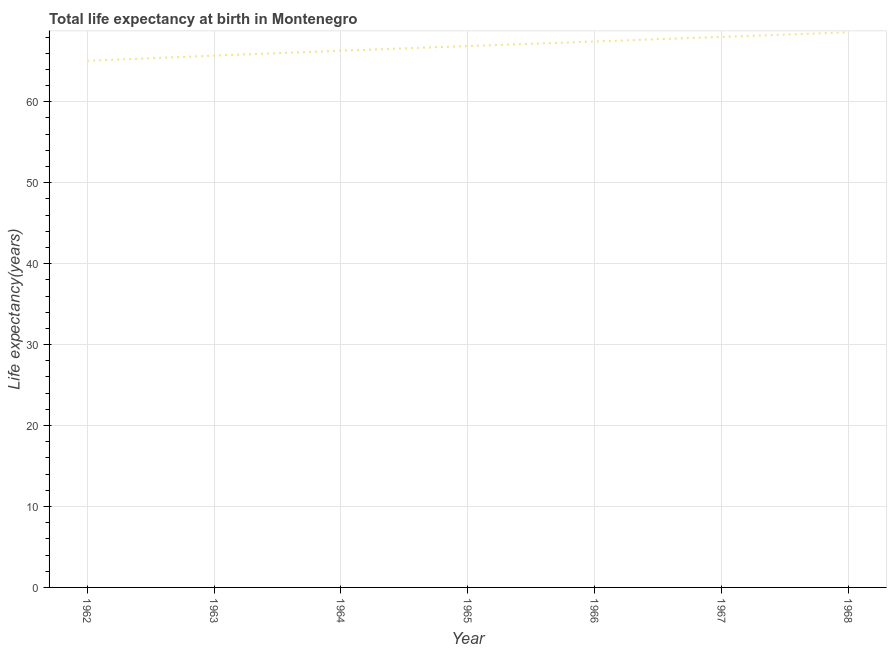What is the life expectancy at birth in 1968?
Provide a short and direct response. 68.59. Across all years, what is the maximum life expectancy at birth?
Provide a short and direct response. 68.59. Across all years, what is the minimum life expectancy at birth?
Make the answer very short. 65.06. In which year was the life expectancy at birth maximum?
Offer a terse response. 1968. What is the sum of the life expectancy at birth?
Your answer should be compact. 468. What is the difference between the life expectancy at birth in 1967 and 1968?
Your answer should be compact. -0.58. What is the average life expectancy at birth per year?
Your answer should be very brief. 66.86. What is the median life expectancy at birth?
Provide a succinct answer. 66.88. In how many years, is the life expectancy at birth greater than 4 years?
Keep it short and to the point. 7. What is the ratio of the life expectancy at birth in 1964 to that in 1968?
Make the answer very short. 0.97. Is the life expectancy at birth in 1965 less than that in 1967?
Keep it short and to the point. Yes. Is the difference between the life expectancy at birth in 1963 and 1967 greater than the difference between any two years?
Ensure brevity in your answer.  No. What is the difference between the highest and the second highest life expectancy at birth?
Make the answer very short. 0.58. What is the difference between the highest and the lowest life expectancy at birth?
Ensure brevity in your answer.  3.53. Does the life expectancy at birth monotonically increase over the years?
Provide a succinct answer. Yes. How many years are there in the graph?
Keep it short and to the point. 7. What is the difference between two consecutive major ticks on the Y-axis?
Your answer should be compact. 10. Are the values on the major ticks of Y-axis written in scientific E-notation?
Make the answer very short. No. Does the graph contain grids?
Your answer should be compact. Yes. What is the title of the graph?
Give a very brief answer. Total life expectancy at birth in Montenegro. What is the label or title of the X-axis?
Provide a short and direct response. Year. What is the label or title of the Y-axis?
Make the answer very short. Life expectancy(years). What is the Life expectancy(years) of 1962?
Your response must be concise. 65.06. What is the Life expectancy(years) of 1963?
Offer a terse response. 65.7. What is the Life expectancy(years) in 1964?
Provide a succinct answer. 66.31. What is the Life expectancy(years) of 1965?
Your answer should be very brief. 66.88. What is the Life expectancy(years) of 1966?
Ensure brevity in your answer.  67.45. What is the Life expectancy(years) of 1967?
Your response must be concise. 68.01. What is the Life expectancy(years) of 1968?
Keep it short and to the point. 68.59. What is the difference between the Life expectancy(years) in 1962 and 1963?
Offer a terse response. -0.64. What is the difference between the Life expectancy(years) in 1962 and 1964?
Your answer should be very brief. -1.25. What is the difference between the Life expectancy(years) in 1962 and 1965?
Your answer should be very brief. -1.82. What is the difference between the Life expectancy(years) in 1962 and 1966?
Your response must be concise. -2.39. What is the difference between the Life expectancy(years) in 1962 and 1967?
Provide a short and direct response. -2.95. What is the difference between the Life expectancy(years) in 1962 and 1968?
Keep it short and to the point. -3.53. What is the difference between the Life expectancy(years) in 1963 and 1964?
Your answer should be compact. -0.61. What is the difference between the Life expectancy(years) in 1963 and 1965?
Ensure brevity in your answer.  -1.18. What is the difference between the Life expectancy(years) in 1963 and 1966?
Make the answer very short. -1.74. What is the difference between the Life expectancy(years) in 1963 and 1967?
Ensure brevity in your answer.  -2.31. What is the difference between the Life expectancy(years) in 1963 and 1968?
Provide a succinct answer. -2.89. What is the difference between the Life expectancy(years) in 1964 and 1965?
Make the answer very short. -0.58. What is the difference between the Life expectancy(years) in 1964 and 1966?
Your answer should be very brief. -1.14. What is the difference between the Life expectancy(years) in 1964 and 1967?
Your response must be concise. -1.7. What is the difference between the Life expectancy(years) in 1964 and 1968?
Your answer should be very brief. -2.28. What is the difference between the Life expectancy(years) in 1965 and 1966?
Provide a short and direct response. -0.56. What is the difference between the Life expectancy(years) in 1965 and 1967?
Make the answer very short. -1.13. What is the difference between the Life expectancy(years) in 1965 and 1968?
Give a very brief answer. -1.7. What is the difference between the Life expectancy(years) in 1966 and 1967?
Your answer should be very brief. -0.57. What is the difference between the Life expectancy(years) in 1966 and 1968?
Give a very brief answer. -1.14. What is the difference between the Life expectancy(years) in 1967 and 1968?
Make the answer very short. -0.58. What is the ratio of the Life expectancy(years) in 1962 to that in 1965?
Offer a very short reply. 0.97. What is the ratio of the Life expectancy(years) in 1962 to that in 1968?
Provide a short and direct response. 0.95. What is the ratio of the Life expectancy(years) in 1963 to that in 1964?
Your answer should be very brief. 0.99. What is the ratio of the Life expectancy(years) in 1963 to that in 1966?
Your answer should be very brief. 0.97. What is the ratio of the Life expectancy(years) in 1963 to that in 1968?
Keep it short and to the point. 0.96. What is the ratio of the Life expectancy(years) in 1964 to that in 1965?
Make the answer very short. 0.99. What is the ratio of the Life expectancy(years) in 1964 to that in 1966?
Your answer should be very brief. 0.98. What is the ratio of the Life expectancy(years) in 1964 to that in 1967?
Provide a short and direct response. 0.97. What is the ratio of the Life expectancy(years) in 1965 to that in 1968?
Give a very brief answer. 0.97. What is the ratio of the Life expectancy(years) in 1966 to that in 1967?
Give a very brief answer. 0.99. 